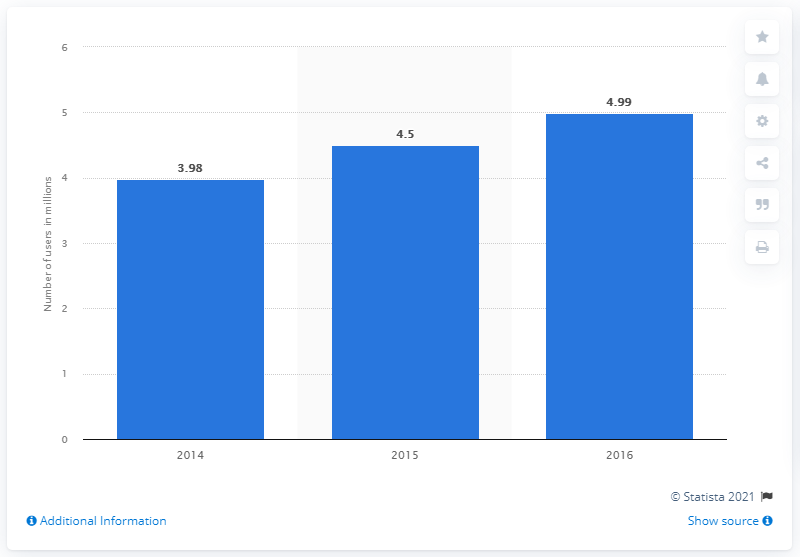Mention a couple of crucial points in this snapshot. According to data from 2015, there were approximately 4.5 million Twitter users in Argentina. 